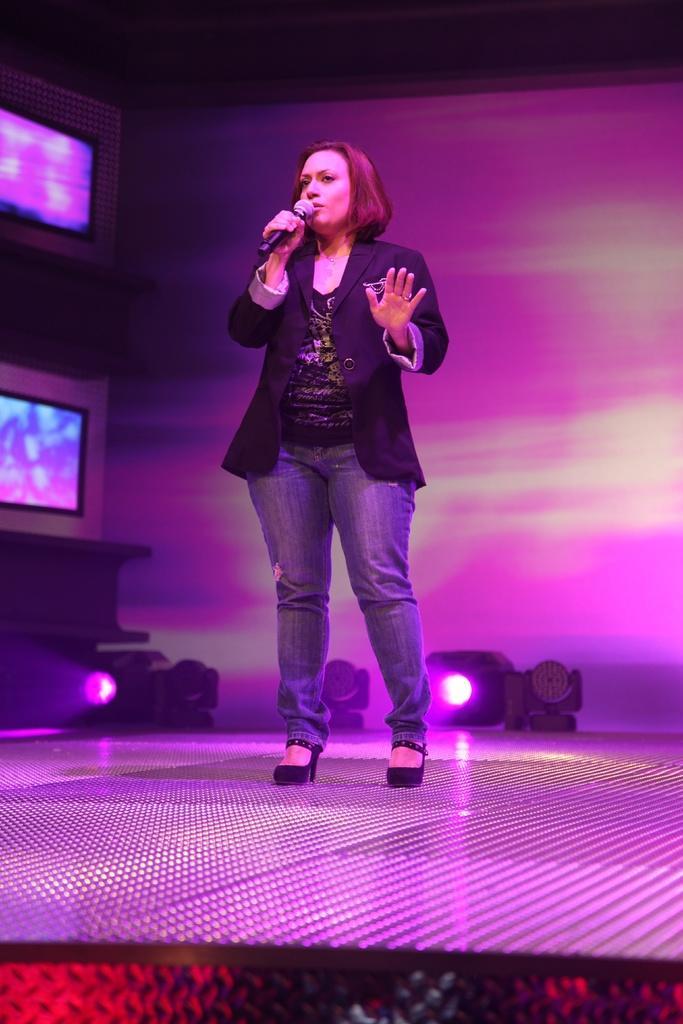Can you describe this image briefly? In this image in the center there is one woman standing and she is holding a mike, and it seems that she is talking. In the background there are some monitors and a wall and some lights, at the bottom there is floor. 